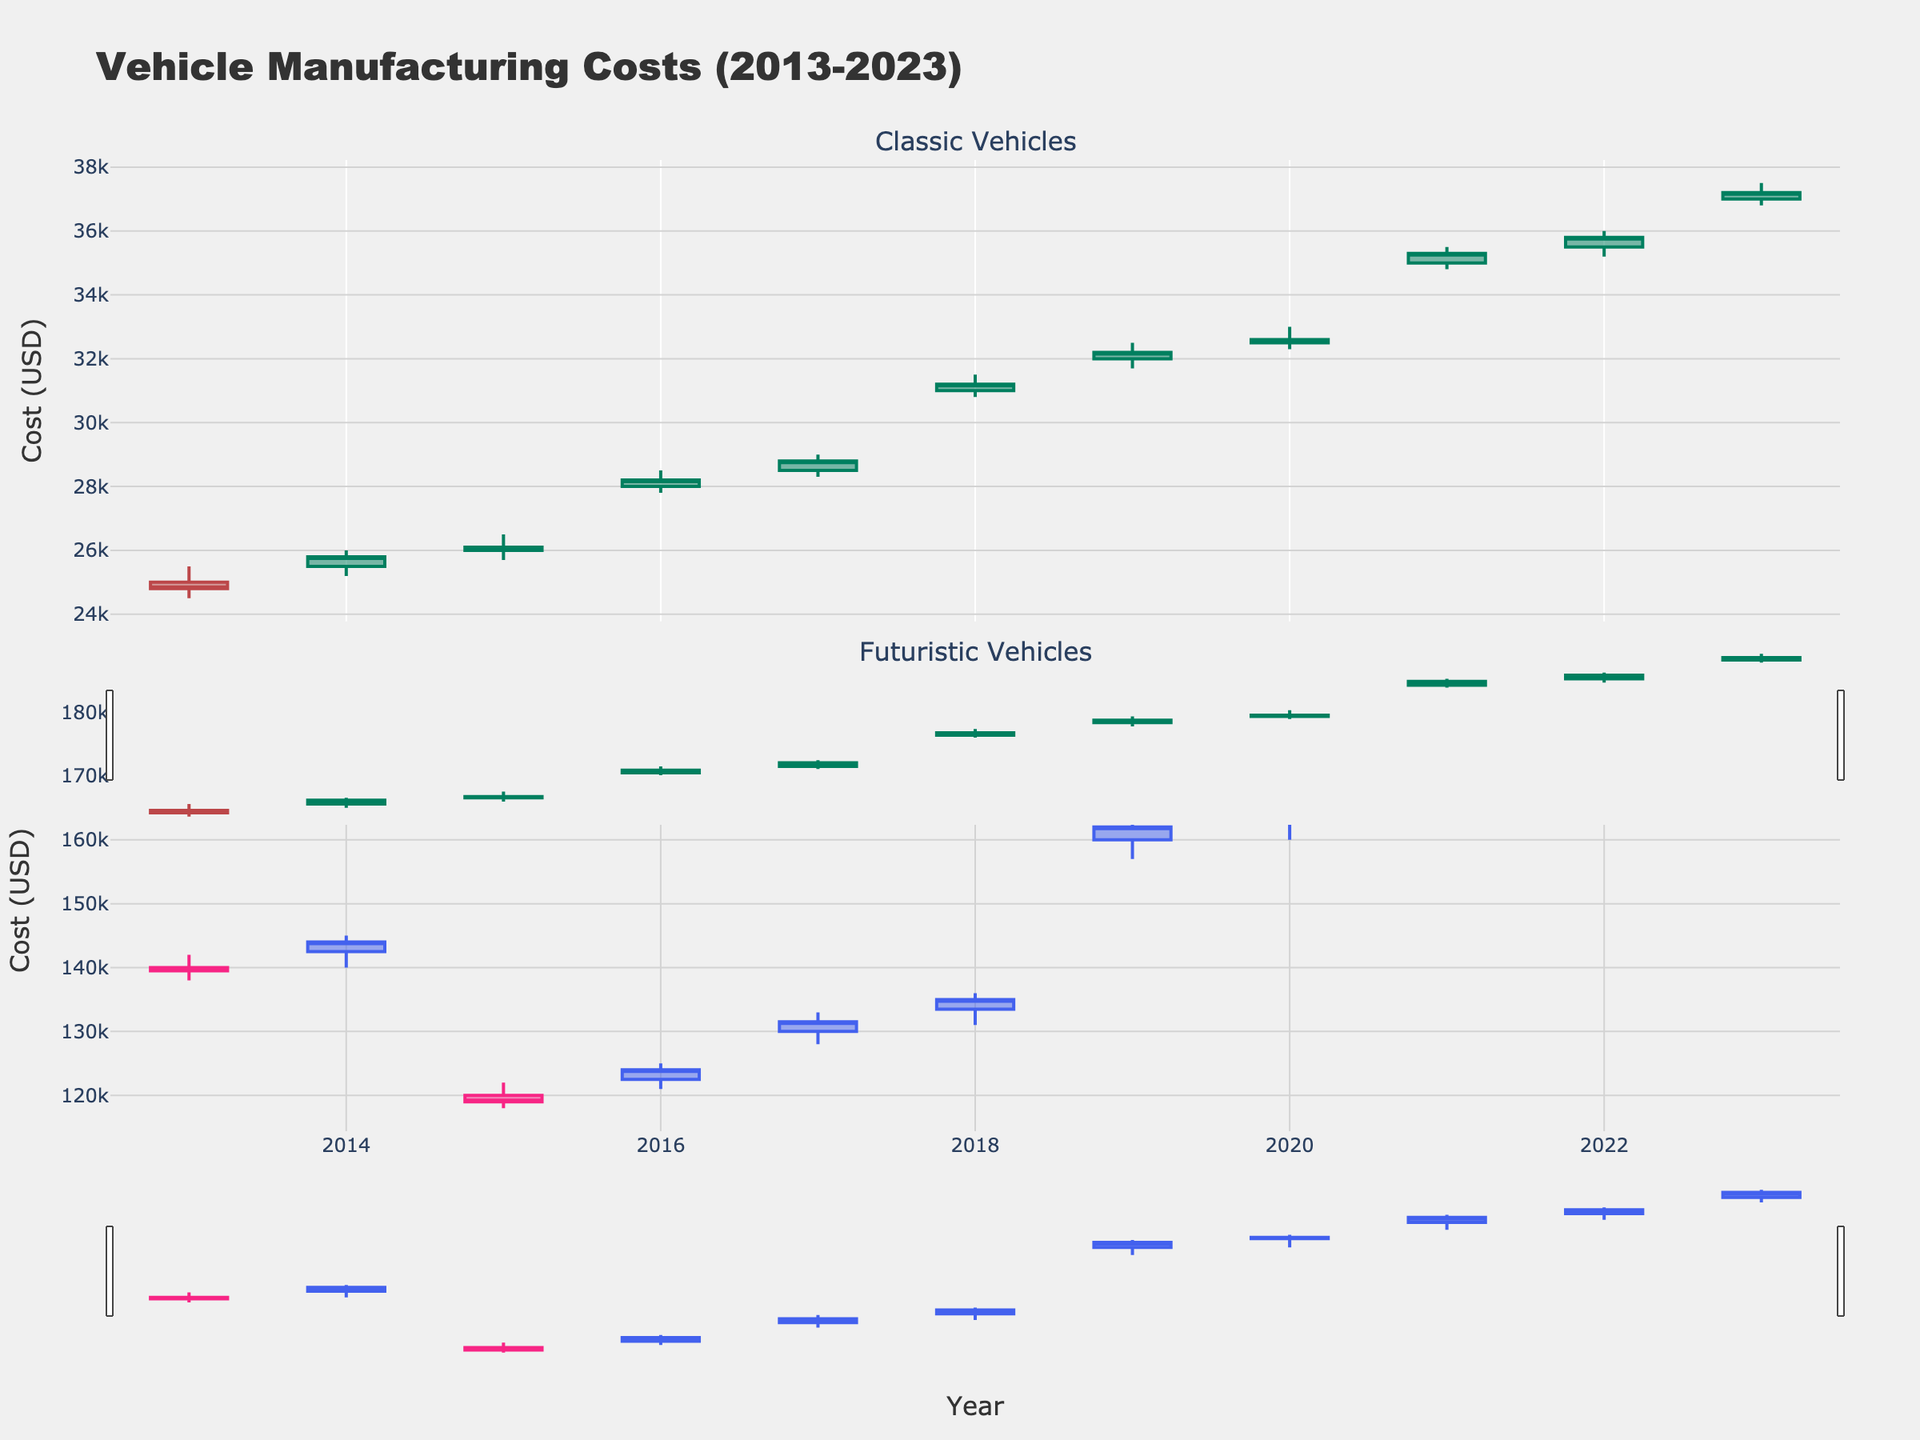What's the title of the figure? The title is located at the top of the figure.
Answer: Vehicle Manufacturing Costs (2013-2023) How many subplots are there in the figure? The figure is divided into two distinct sections, one for Classic Vehicles and one for Futuristic Vehicles. Thus, it contains two subplots.
Answer: 2 What is the highest manufacturing cost recorded for a Classic vehicle? The highest point in the Classic vehicles section can be found at 37500 USD for the "Porsche 911" in 2023, noted by the peak in the upper candlestick wick.
Answer: 37500 In which year did the "Lucid Air" model reach its highest closing cost, and what was the value? For the "Lucid Air," in the subplot for Futuristic Vehicles, the highest closing cost is noted in 2022 at 175000 USD. This can be seen at the end of the candlestick body for that year.
Answer: 2022, 175000 What is the general trend of manufacturing costs for Classic vehicles over the decade 2013-2023? Analyzing the candlestick traces from 2013 to 2023, the trend appears to be an increase in the manufacturing costs. Each subsequent year shows candles forming at higher levels than the previous year.
Answer: Increasing Which category, Classic or Futuristic, had the highest closing cost in this data set, and what was the model and year? Comparing the highest closing costs between the two subplots, the "Porsche Taycan" in the Futuristic category had the highest at 182000 USD in 2023, as noted by the tall candlestick in that section.
Answer: Futuristic, Porsche Taycan, 2023, 182000 How does the manufacturing cost for the "Tesla Model S" change from 2015 to 2016? By comparing the candlestick positions in both years for the "Tesla Model S," you can see an increase in both the opening and closing costs from 2015 (Open: 120000, Close: 119000) to 2016 (Open: 122500, Close: 124000).
Answer: Increase from 120000 (open) to 122500 (open) and 119000 (close) to 124000 (close) What does a candlestick with a long wick and short body indicate about manufacturing costs in that year? It indicates a high volatility in manufacturing costs within that year. A long wick and short body show that the costs fluctuated greatly but closed near the opening value, implying significant intra-year variability.
Answer: High volatility with significant intra-year variability Is there a year where both Classic and Futuristic vehicle categories show a closing cost increase from the previous year? In 2019, the Classic "Chevrolet Corvette" and Futuristic "Faraday Future FF 91" both show increases from their previous year's closing costs. The 2019 closing costs are higher than those of 2018 for both models.
Answer: Yes, 2019 In which year did the "Dodge Challenger" model experience the steepest increase in manufacturing cost? By comparing the size of the candlestick bodies across years for the "Dodge Challenger," the steepest increase happened from 2020 to 2021 as the candlestick body between these years is the greatest.
Answer: 2021 